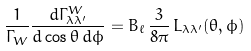<formula> <loc_0><loc_0><loc_500><loc_500>\frac { 1 } { \Gamma _ { W } } \frac { d \Gamma _ { \lambda \lambda ^ { \prime } } ^ { W } } { d \cos \theta \, d \phi } = B _ { \ell } \, \frac { 3 } { 8 \pi } \, L _ { \lambda \lambda ^ { \prime } } ( \theta , \phi )</formula> 